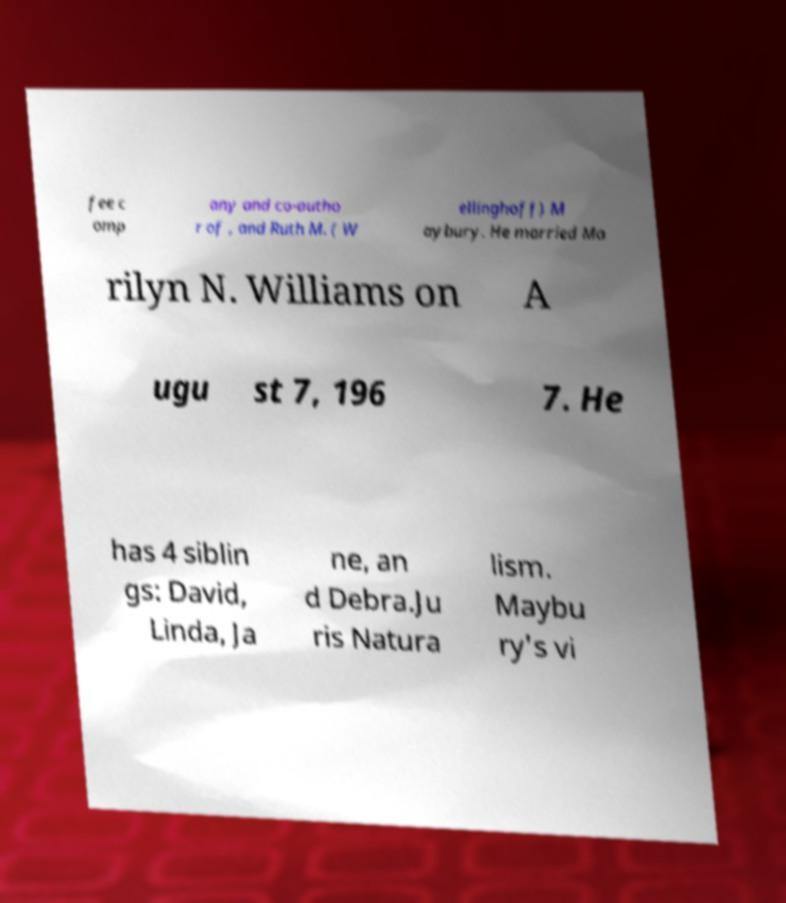What messages or text are displayed in this image? I need them in a readable, typed format. fee c omp any and co-autho r of , and Ruth M. ( W ellinghoff) M aybury. He married Ma rilyn N. Williams on A ugu st 7, 196 7. He has 4 siblin gs: David, Linda, Ja ne, an d Debra.Ju ris Natura lism. Maybu ry's vi 